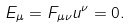Convert formula to latex. <formula><loc_0><loc_0><loc_500><loc_500>E _ { \mu } = F _ { \mu \nu } u ^ { \nu } = 0 .</formula> 